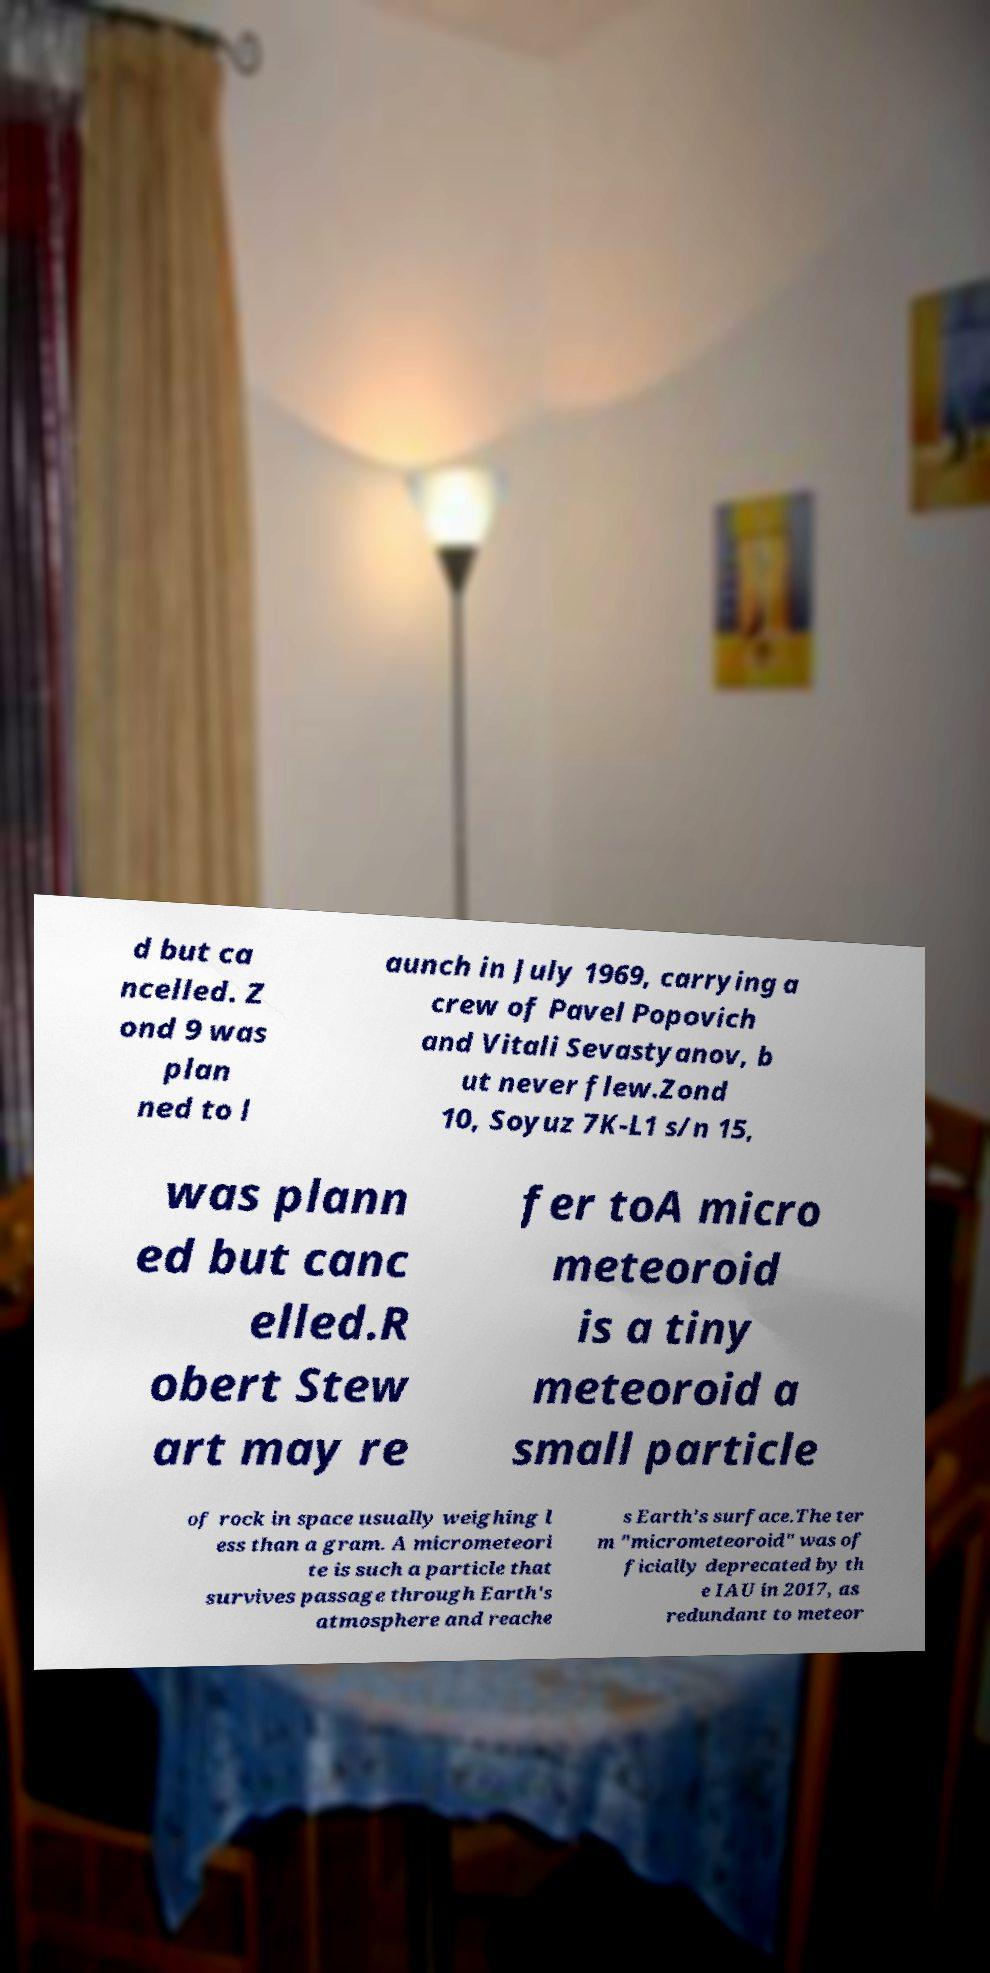I need the written content from this picture converted into text. Can you do that? d but ca ncelled. Z ond 9 was plan ned to l aunch in July 1969, carrying a crew of Pavel Popovich and Vitali Sevastyanov, b ut never flew.Zond 10, Soyuz 7K-L1 s/n 15, was plann ed but canc elled.R obert Stew art may re fer toA micro meteoroid is a tiny meteoroid a small particle of rock in space usually weighing l ess than a gram. A micrometeori te is such a particle that survives passage through Earth's atmosphere and reache s Earth's surface.The ter m "micrometeoroid" was of ficially deprecated by th e IAU in 2017, as redundant to meteor 